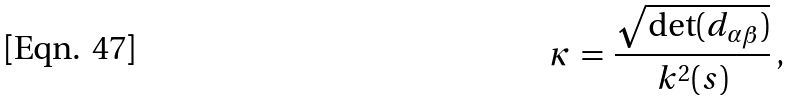<formula> <loc_0><loc_0><loc_500><loc_500>\kappa \, = \, \frac { \sqrt { \det ( d _ { \alpha \beta } ) } } { k ^ { 2 } ( s ) } \, { , }</formula> 